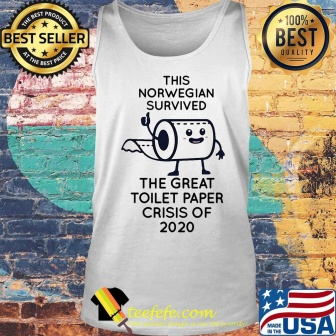Write a fictional story about the tank top becoming a priceless artifact in the year 3000. In the year 3000, archaeologists uncovered a remarkable artifact from the early 21st century—a white tank top. This tank top featured a comical cartoon of a toilet paper roll, bearing arms and legs, in a victorious stance. The text 'This Norwegian survived the great toilet paper crisis of 2020' accompanied the illustration, intriguing researchers. As they delved into the history behind this relic, they discovered it marked a time during the COVID-19 pandemic when toilet paper was scarce. Over centuries, this simple piece of clothing had transformed into an emblem of human perseverance and creative expression during crises. Stored in the grand Museum of Human Ingenuity, the tank top became a celebrated artifact, symbolizing how humanity found strength in humor and unity in times of global adversity. Its cultural significance rendered it priceless, telling stories of survival and laughter to future generations. 